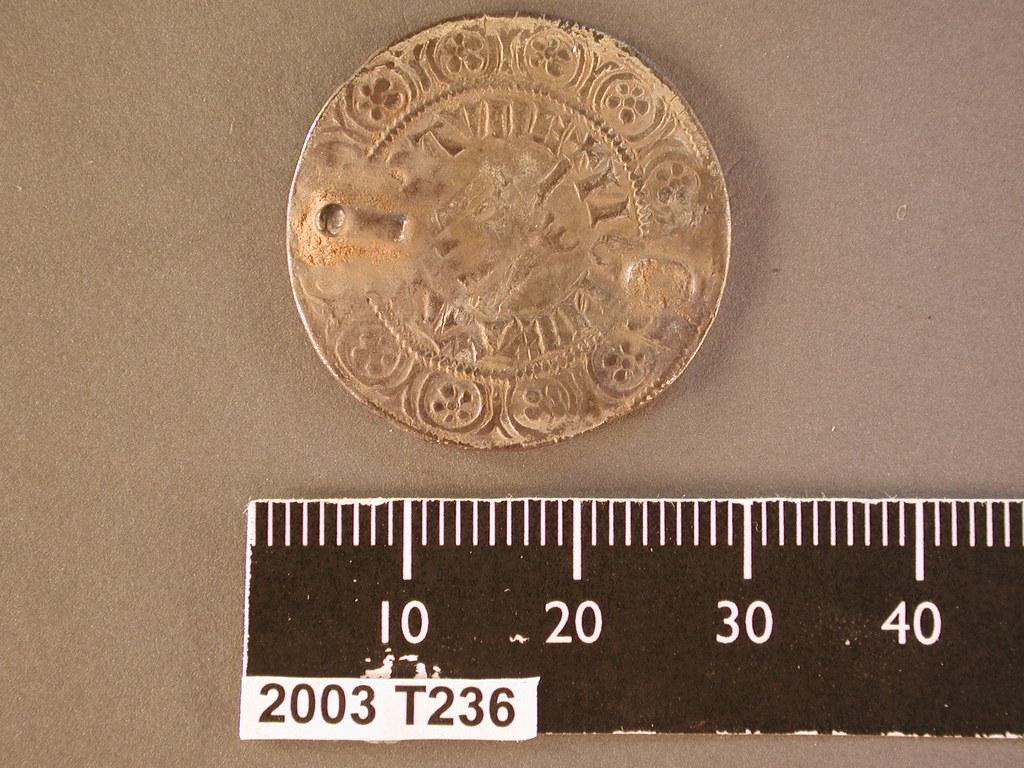<image>
Summarize the visual content of the image. A ruler shows the width of an old coin to be approximately 30. 